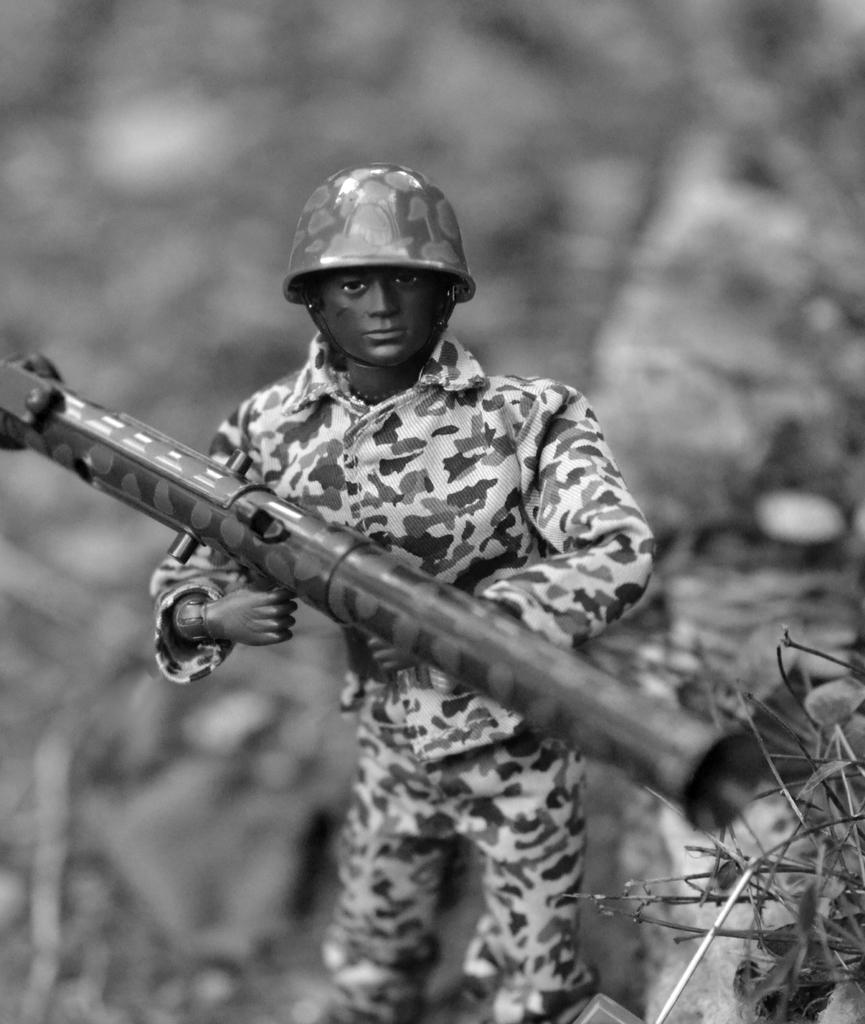What is the color scheme of the image? The image is black and white. What is the main subject of the image? There is a picture of a doll in the image. What is the doll holding in its hand? The doll is holding a gun in its hand. Can you see any curtains in the image? There are no curtains present in the image. Is there a playground visible in the image? There is no playground visible in the image. 